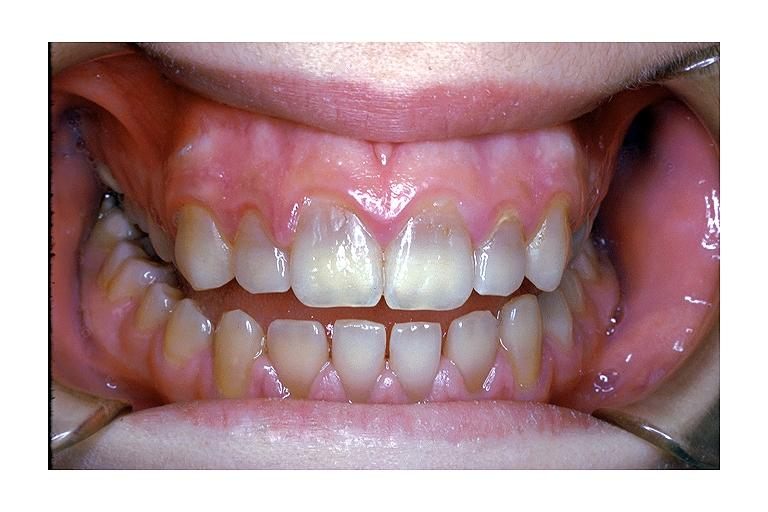s oral present?
Answer the question using a single word or phrase. Yes 